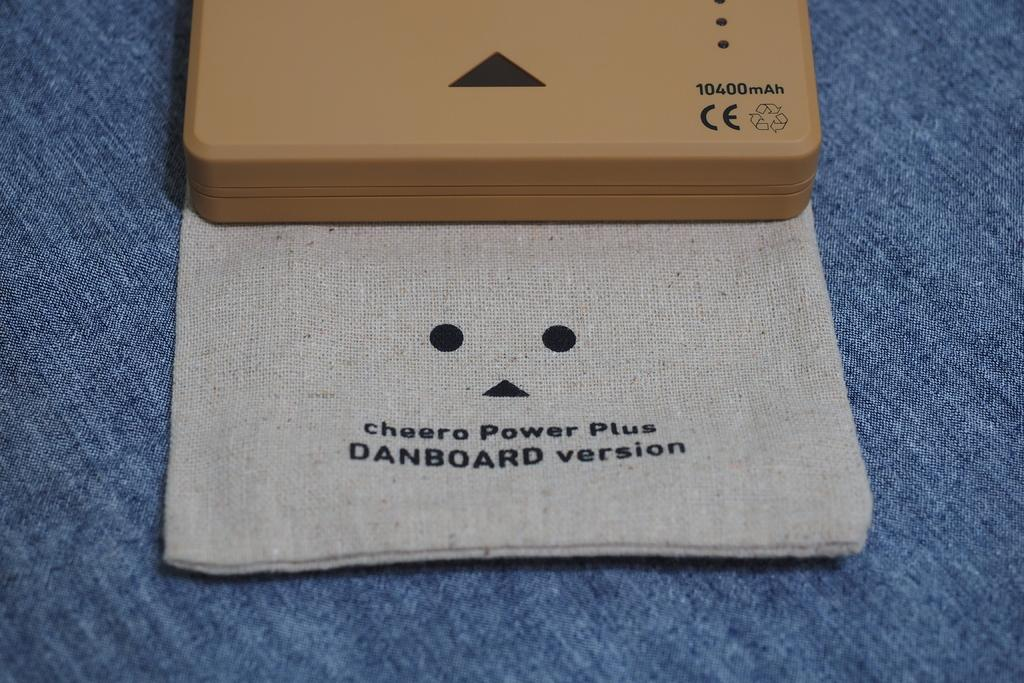<image>
Offer a succinct explanation of the picture presented. a box and a cloth bag labeled Cheero Power Plus Danboard Version 